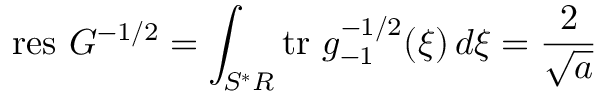Convert formula to latex. <formula><loc_0><loc_0><loc_500><loc_500>r e s \ G ^ { - 1 / 2 } = \int _ { S ^ { * } R } t r \ g _ { - 1 } ^ { - 1 / 2 } ( \xi ) \, d \xi = \frac { 2 } { \sqrt { a } }</formula> 